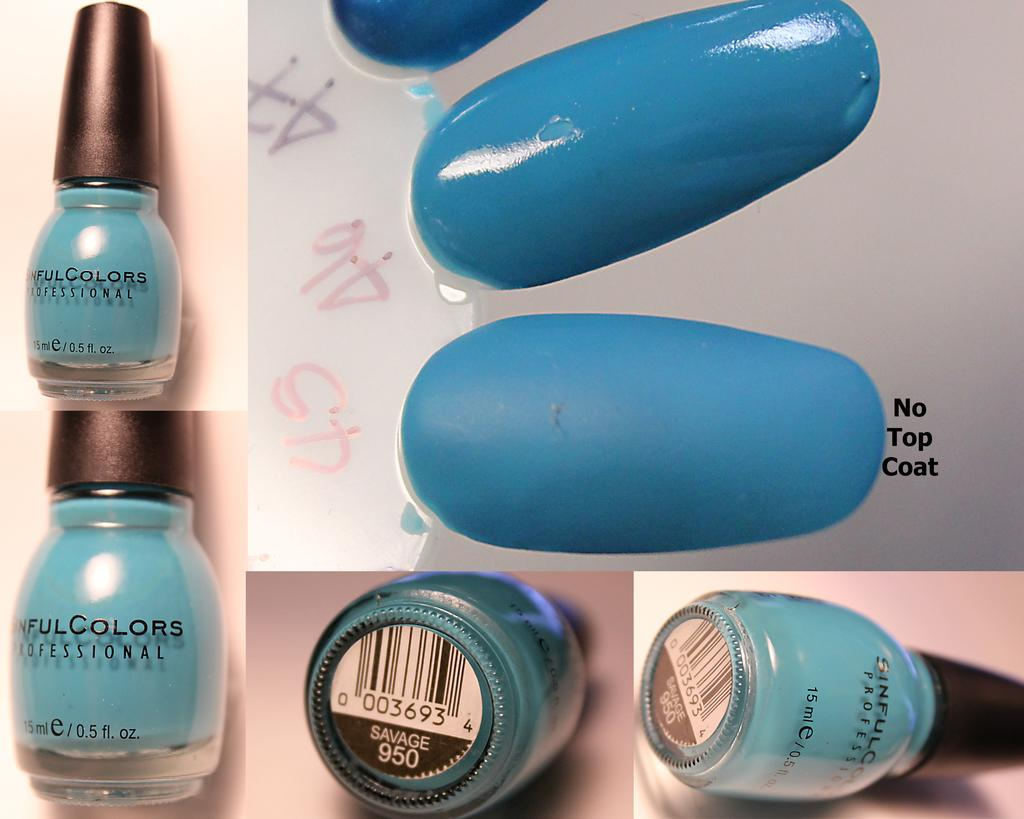<image>
Render a clear and concise summary of the photo. A bottle of Sinful Colors nail polish is displayed in the color Savage. 